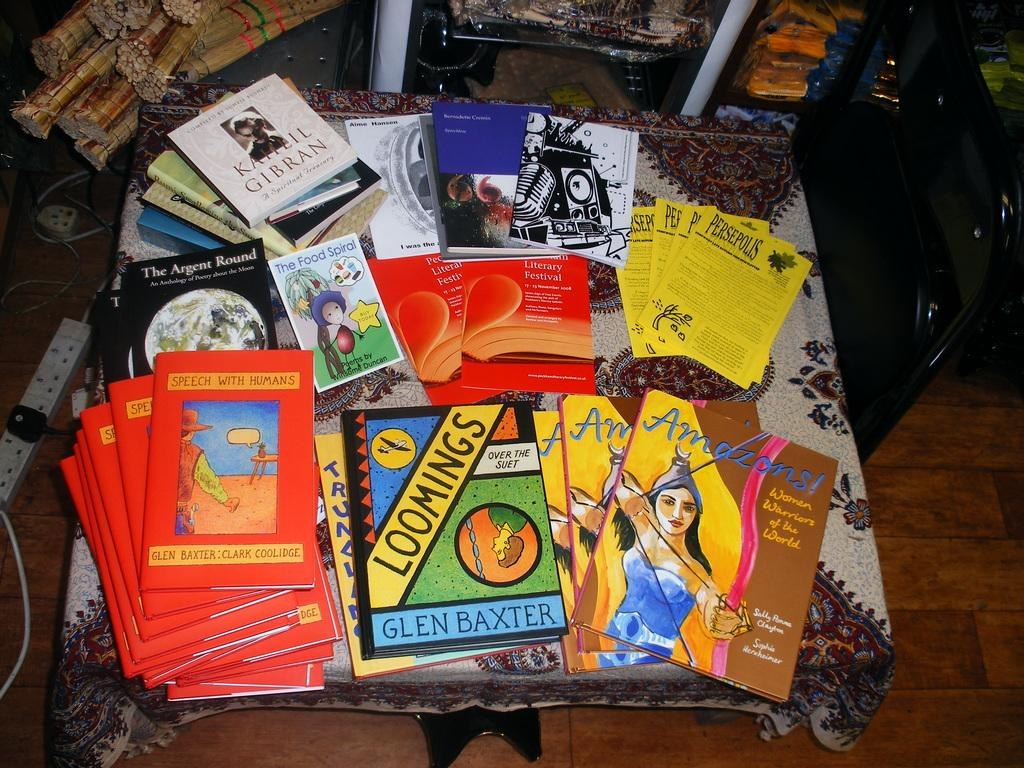Provide a one-sentence caption for the provided image. A table full of assorted books includes a couple of titles by Glen Baxter. 